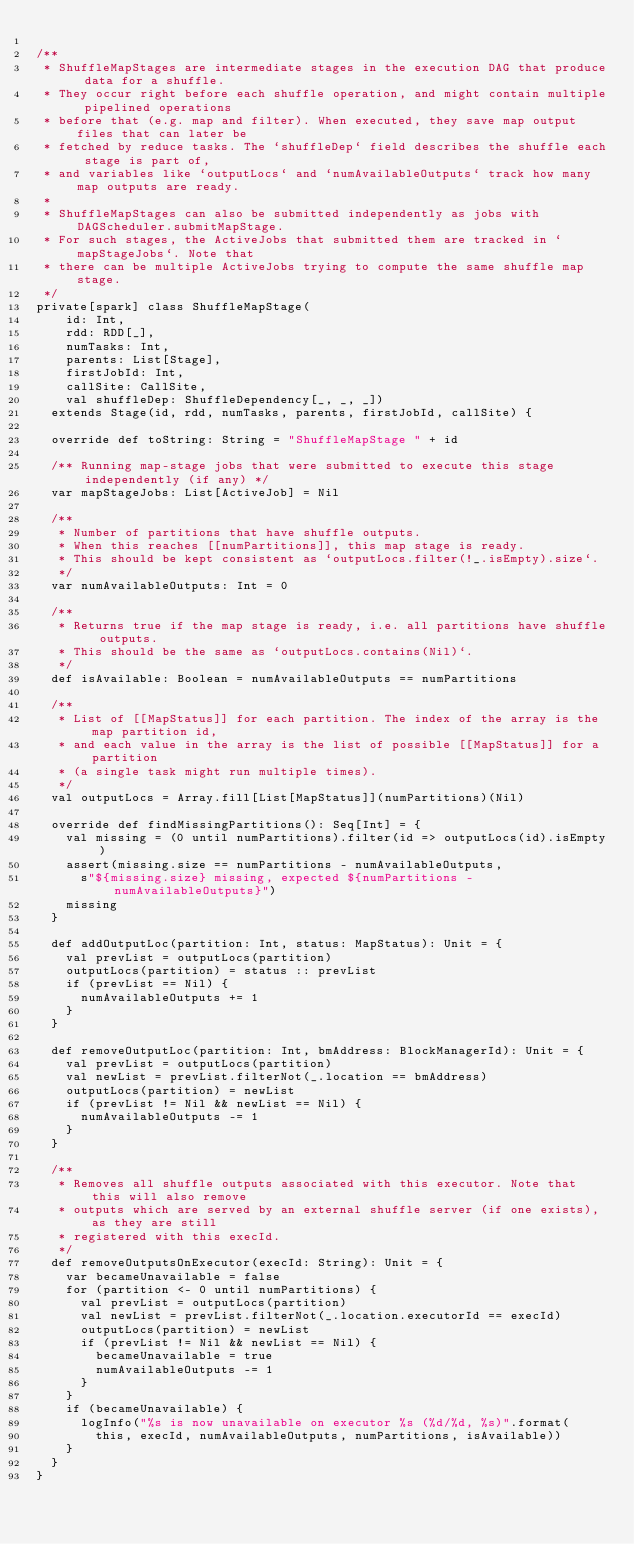Convert code to text. <code><loc_0><loc_0><loc_500><loc_500><_Scala_>
/**
 * ShuffleMapStages are intermediate stages in the execution DAG that produce data for a shuffle.
 * They occur right before each shuffle operation, and might contain multiple pipelined operations
 * before that (e.g. map and filter). When executed, they save map output files that can later be
 * fetched by reduce tasks. The `shuffleDep` field describes the shuffle each stage is part of,
 * and variables like `outputLocs` and `numAvailableOutputs` track how many map outputs are ready.
 *
 * ShuffleMapStages can also be submitted independently as jobs with DAGScheduler.submitMapStage.
 * For such stages, the ActiveJobs that submitted them are tracked in `mapStageJobs`. Note that
 * there can be multiple ActiveJobs trying to compute the same shuffle map stage.
 */
private[spark] class ShuffleMapStage(
    id: Int,
    rdd: RDD[_],
    numTasks: Int,
    parents: List[Stage],
    firstJobId: Int,
    callSite: CallSite,
    val shuffleDep: ShuffleDependency[_, _, _])
  extends Stage(id, rdd, numTasks, parents, firstJobId, callSite) {

  override def toString: String = "ShuffleMapStage " + id

  /** Running map-stage jobs that were submitted to execute this stage independently (if any) */
  var mapStageJobs: List[ActiveJob] = Nil

  /**
   * Number of partitions that have shuffle outputs.
   * When this reaches [[numPartitions]], this map stage is ready.
   * This should be kept consistent as `outputLocs.filter(!_.isEmpty).size`.
   */
  var numAvailableOutputs: Int = 0

  /**
   * Returns true if the map stage is ready, i.e. all partitions have shuffle outputs.
   * This should be the same as `outputLocs.contains(Nil)`.
   */
  def isAvailable: Boolean = numAvailableOutputs == numPartitions

  /**
   * List of [[MapStatus]] for each partition. The index of the array is the map partition id,
   * and each value in the array is the list of possible [[MapStatus]] for a partition
   * (a single task might run multiple times).
   */
  val outputLocs = Array.fill[List[MapStatus]](numPartitions)(Nil)

  override def findMissingPartitions(): Seq[Int] = {
    val missing = (0 until numPartitions).filter(id => outputLocs(id).isEmpty)
    assert(missing.size == numPartitions - numAvailableOutputs,
      s"${missing.size} missing, expected ${numPartitions - numAvailableOutputs}")
    missing
  }

  def addOutputLoc(partition: Int, status: MapStatus): Unit = {
    val prevList = outputLocs(partition)
    outputLocs(partition) = status :: prevList
    if (prevList == Nil) {
      numAvailableOutputs += 1
    }
  }

  def removeOutputLoc(partition: Int, bmAddress: BlockManagerId): Unit = {
    val prevList = outputLocs(partition)
    val newList = prevList.filterNot(_.location == bmAddress)
    outputLocs(partition) = newList
    if (prevList != Nil && newList == Nil) {
      numAvailableOutputs -= 1
    }
  }

  /**
   * Removes all shuffle outputs associated with this executor. Note that this will also remove
   * outputs which are served by an external shuffle server (if one exists), as they are still
   * registered with this execId.
   */
  def removeOutputsOnExecutor(execId: String): Unit = {
    var becameUnavailable = false
    for (partition <- 0 until numPartitions) {
      val prevList = outputLocs(partition)
      val newList = prevList.filterNot(_.location.executorId == execId)
      outputLocs(partition) = newList
      if (prevList != Nil && newList == Nil) {
        becameUnavailable = true
        numAvailableOutputs -= 1
      }
    }
    if (becameUnavailable) {
      logInfo("%s is now unavailable on executor %s (%d/%d, %s)".format(
        this, execId, numAvailableOutputs, numPartitions, isAvailable))
    }
  }
}
</code> 